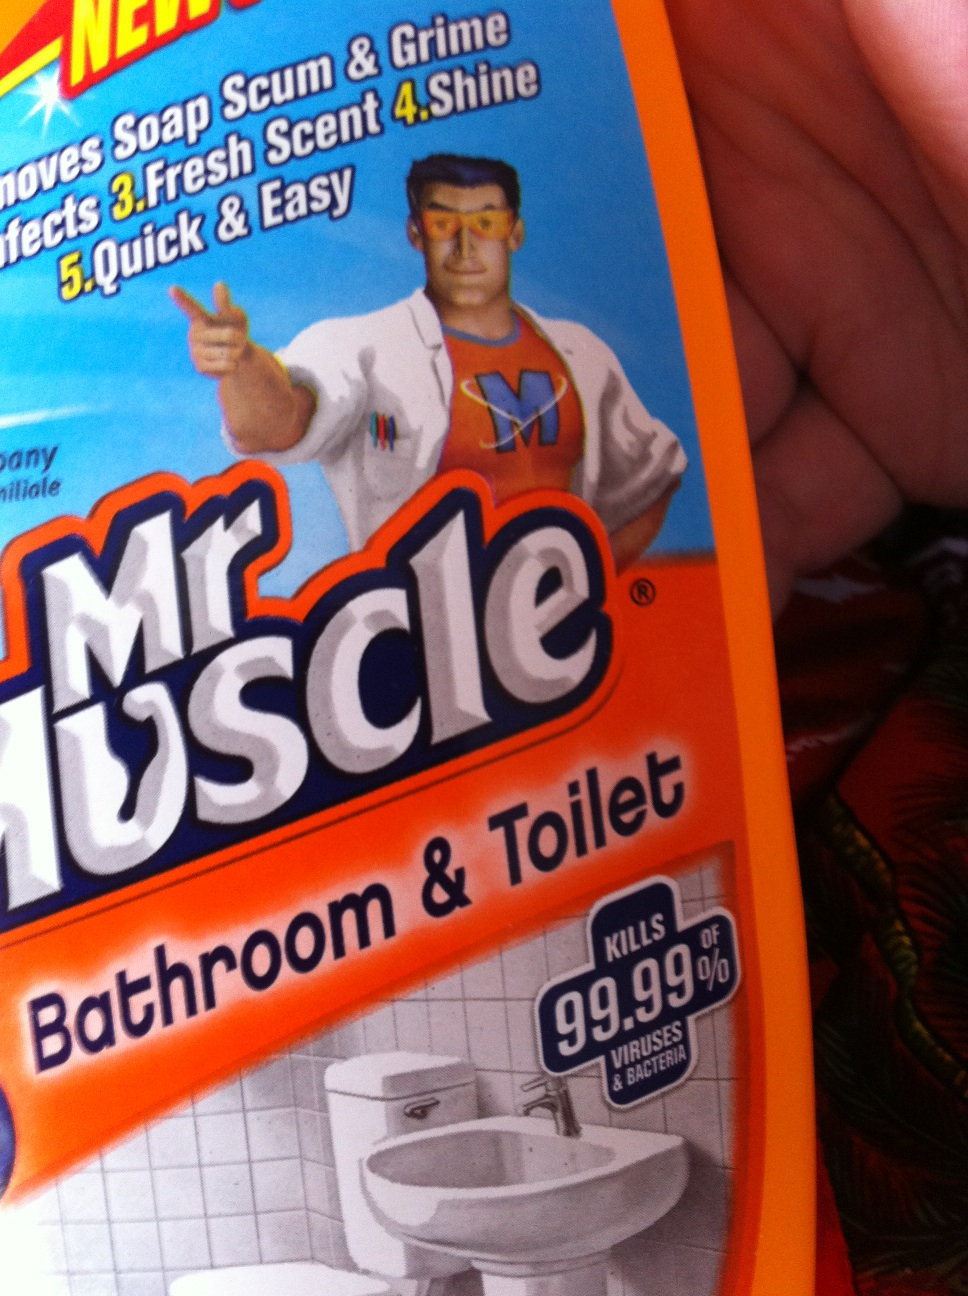What surfaces could I use this product on in my bathroom? The 'Mr. Muscle Bathroom & Toilet' cleaner is suitable for a variety of surfaces in the bathroom including tiles, sinks, bathtubs, and ceramic surfaces. It's important to avoid using it on sensitive materials like marble or natural stone. Always test on a small, inconspicuous area first if you're unsure. 